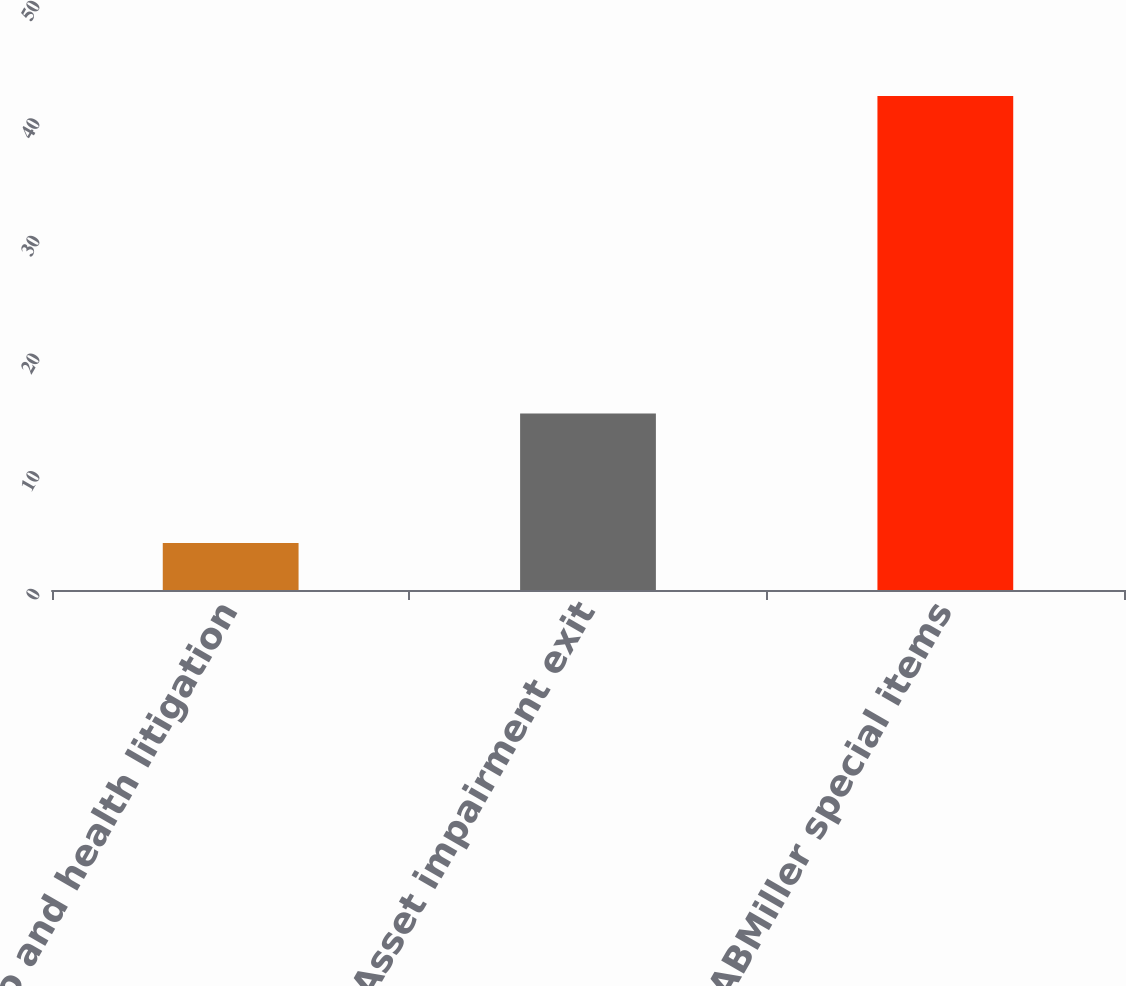<chart> <loc_0><loc_0><loc_500><loc_500><bar_chart><fcel>Tobacco and health litigation<fcel>Asset impairment exit<fcel>SABMiller special items<nl><fcel>4<fcel>15<fcel>42<nl></chart> 